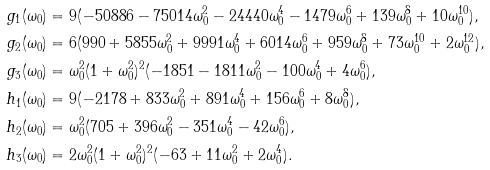<formula> <loc_0><loc_0><loc_500><loc_500>g _ { 1 } ( \omega _ { 0 } ) & = 9 ( - 5 0 8 8 6 - 7 5 0 1 4 \omega _ { 0 } ^ { 2 } - 2 4 4 4 0 \omega _ { 0 } ^ { 4 } - 1 4 7 9 \omega _ { 0 } ^ { 6 } + 1 3 9 \omega _ { 0 } ^ { 8 } + 1 0 \omega _ { 0 } ^ { 1 0 } ) , \\ g _ { 2 } ( \omega _ { 0 } ) & = 6 ( 9 9 0 + 5 8 5 5 \omega _ { 0 } ^ { 2 } + 9 9 9 1 \omega _ { 0 } ^ { 4 } + 6 0 1 4 \omega _ { 0 } ^ { 6 } + 9 5 9 \omega _ { 0 } ^ { 8 } + 7 3 \omega _ { 0 } ^ { 1 0 } + 2 \omega _ { 0 } ^ { 1 2 } ) , \\ g _ { 3 } ( \omega _ { 0 } ) & = \omega _ { 0 } ^ { 2 } ( 1 + \omega _ { 0 } ^ { 2 } ) ^ { 2 } ( - 1 8 5 1 - 1 8 1 1 \omega _ { 0 } ^ { 2 } - 1 0 0 \omega _ { 0 } ^ { 4 } + 4 \omega _ { 0 } ^ { 6 } ) , \\ h _ { 1 } ( \omega _ { 0 } ) & = 9 ( - 2 1 7 8 + 8 3 3 \omega _ { 0 } ^ { 2 } + 8 9 1 \omega _ { 0 } ^ { 4 } + 1 5 6 \omega _ { 0 } ^ { 6 } + 8 \omega _ { 0 } ^ { 8 } ) , \\ h _ { 2 } ( \omega _ { 0 } ) & = \omega _ { 0 } ^ { 2 } ( 7 0 5 + 3 9 6 \omega _ { 0 } ^ { 2 } - 3 5 1 \omega _ { 0 } ^ { 4 } - 4 2 \omega _ { 0 } ^ { 6 } ) , \\ h _ { 3 } ( \omega _ { 0 } ) & = 2 \omega _ { 0 } ^ { 2 } ( 1 + \omega _ { 0 } ^ { 2 } ) ^ { 2 } ( - 6 3 + 1 1 \omega _ { 0 } ^ { 2 } + 2 \omega _ { 0 } ^ { 4 } ) .</formula> 